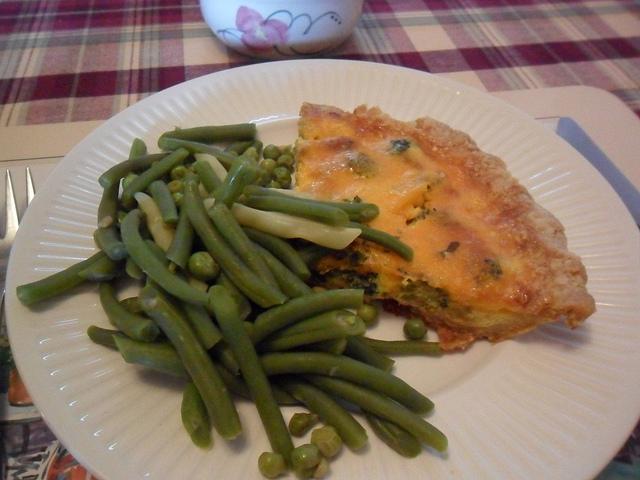What is the food item on the right?
Short answer required. Chicken. How is the chicken cooked?
Give a very brief answer. Baked. What is the flavor of the long green food?
Write a very short answer. Savoury. What kind of veggie is this?
Keep it brief. Green beans. What vegetable is served?
Keep it brief. Green beans. What is the green stuff?
Keep it brief. Green beans. What are the green vegetables?
Write a very short answer. Beans. What are the round green things?
Answer briefly. Peas. What vegetable is green in this dish?
Concise answer only. Green beans. What vegetables are these?
Keep it brief. Green beans. What is under the plate?
Quick response, please. Placemat. Was this dinner from a buffet?
Be succinct. No. What kind of vegetable is on the plate?
Give a very brief answer. Green beans. What vegetable on the plate is green?
Keep it brief. Green beans. What is this green vegetable?
Write a very short answer. Green beans. Is this a pasta dish?
Be succinct. No. What vegetable is on the plate?
Short answer required. Green beans. 